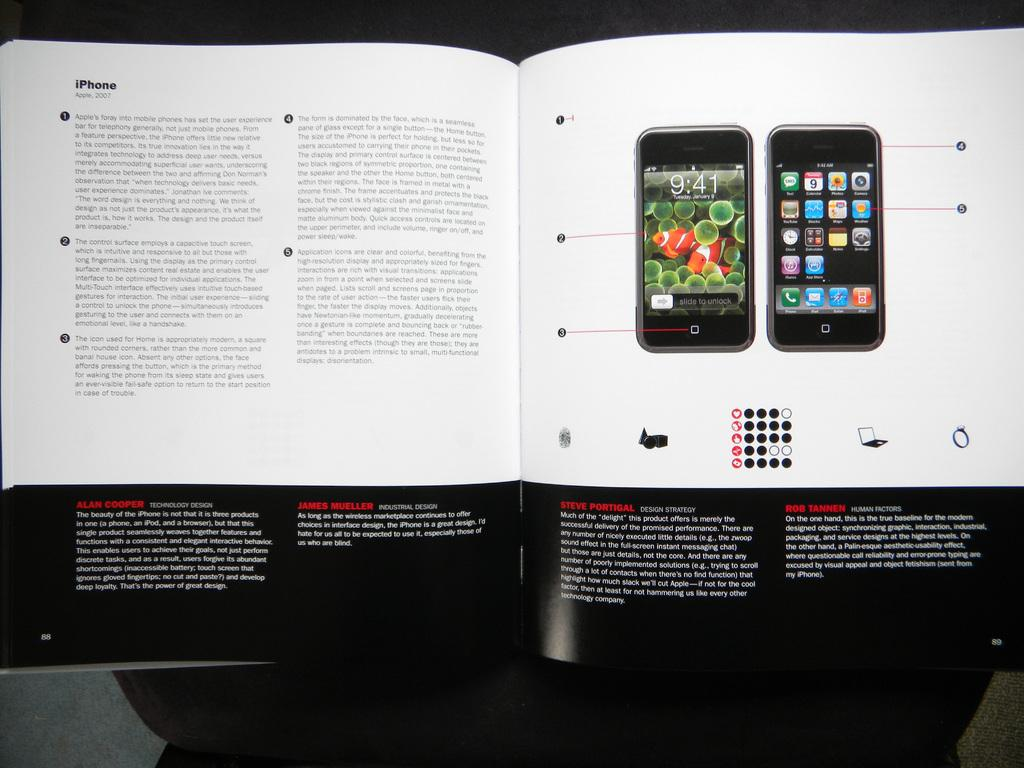<image>
Offer a succinct explanation of the picture presented. A book displaying an iPhone with one section titled Steve Portigal 